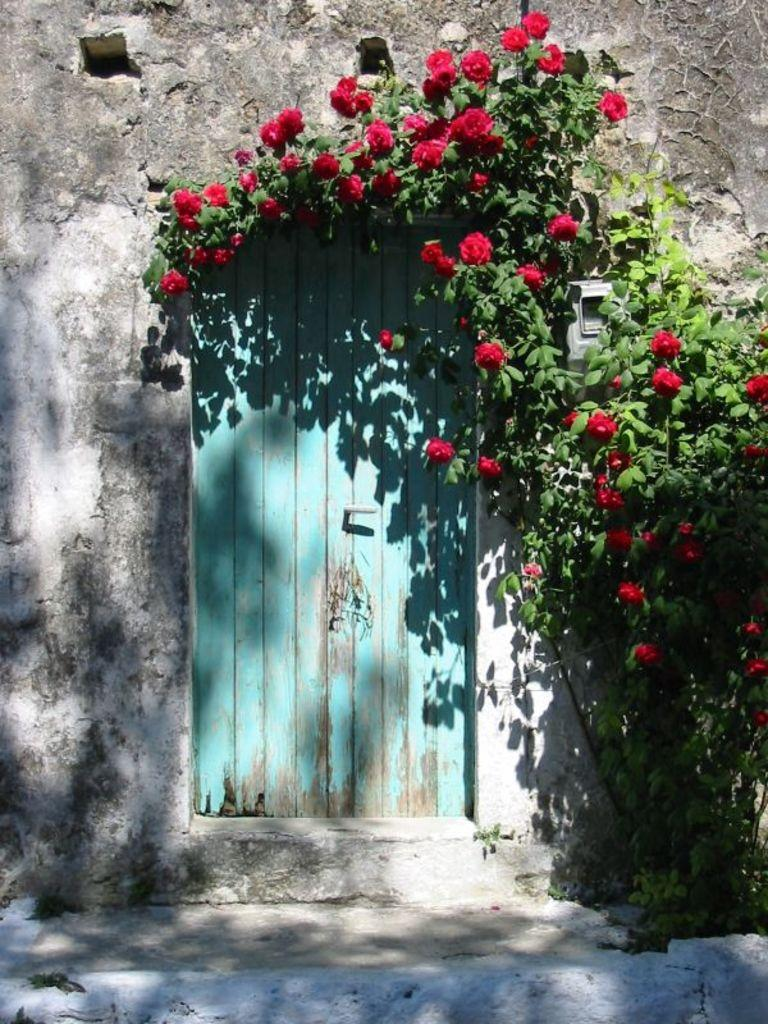What type of plant is present in the image? There is a tree with leaves and flowers in the image. What color are the flowers on the tree? The flowers on the tree are red in color. What type of structure can be seen in the image? There is a wooden door in the image. What feature is present on the wooden door? The wooden door has a door handle. What type of background is visible in the image? There is a wall in the image. What type of produce is being stored in the crate in the image? There is no crate present in the image, so it is not possible to answer that question. 